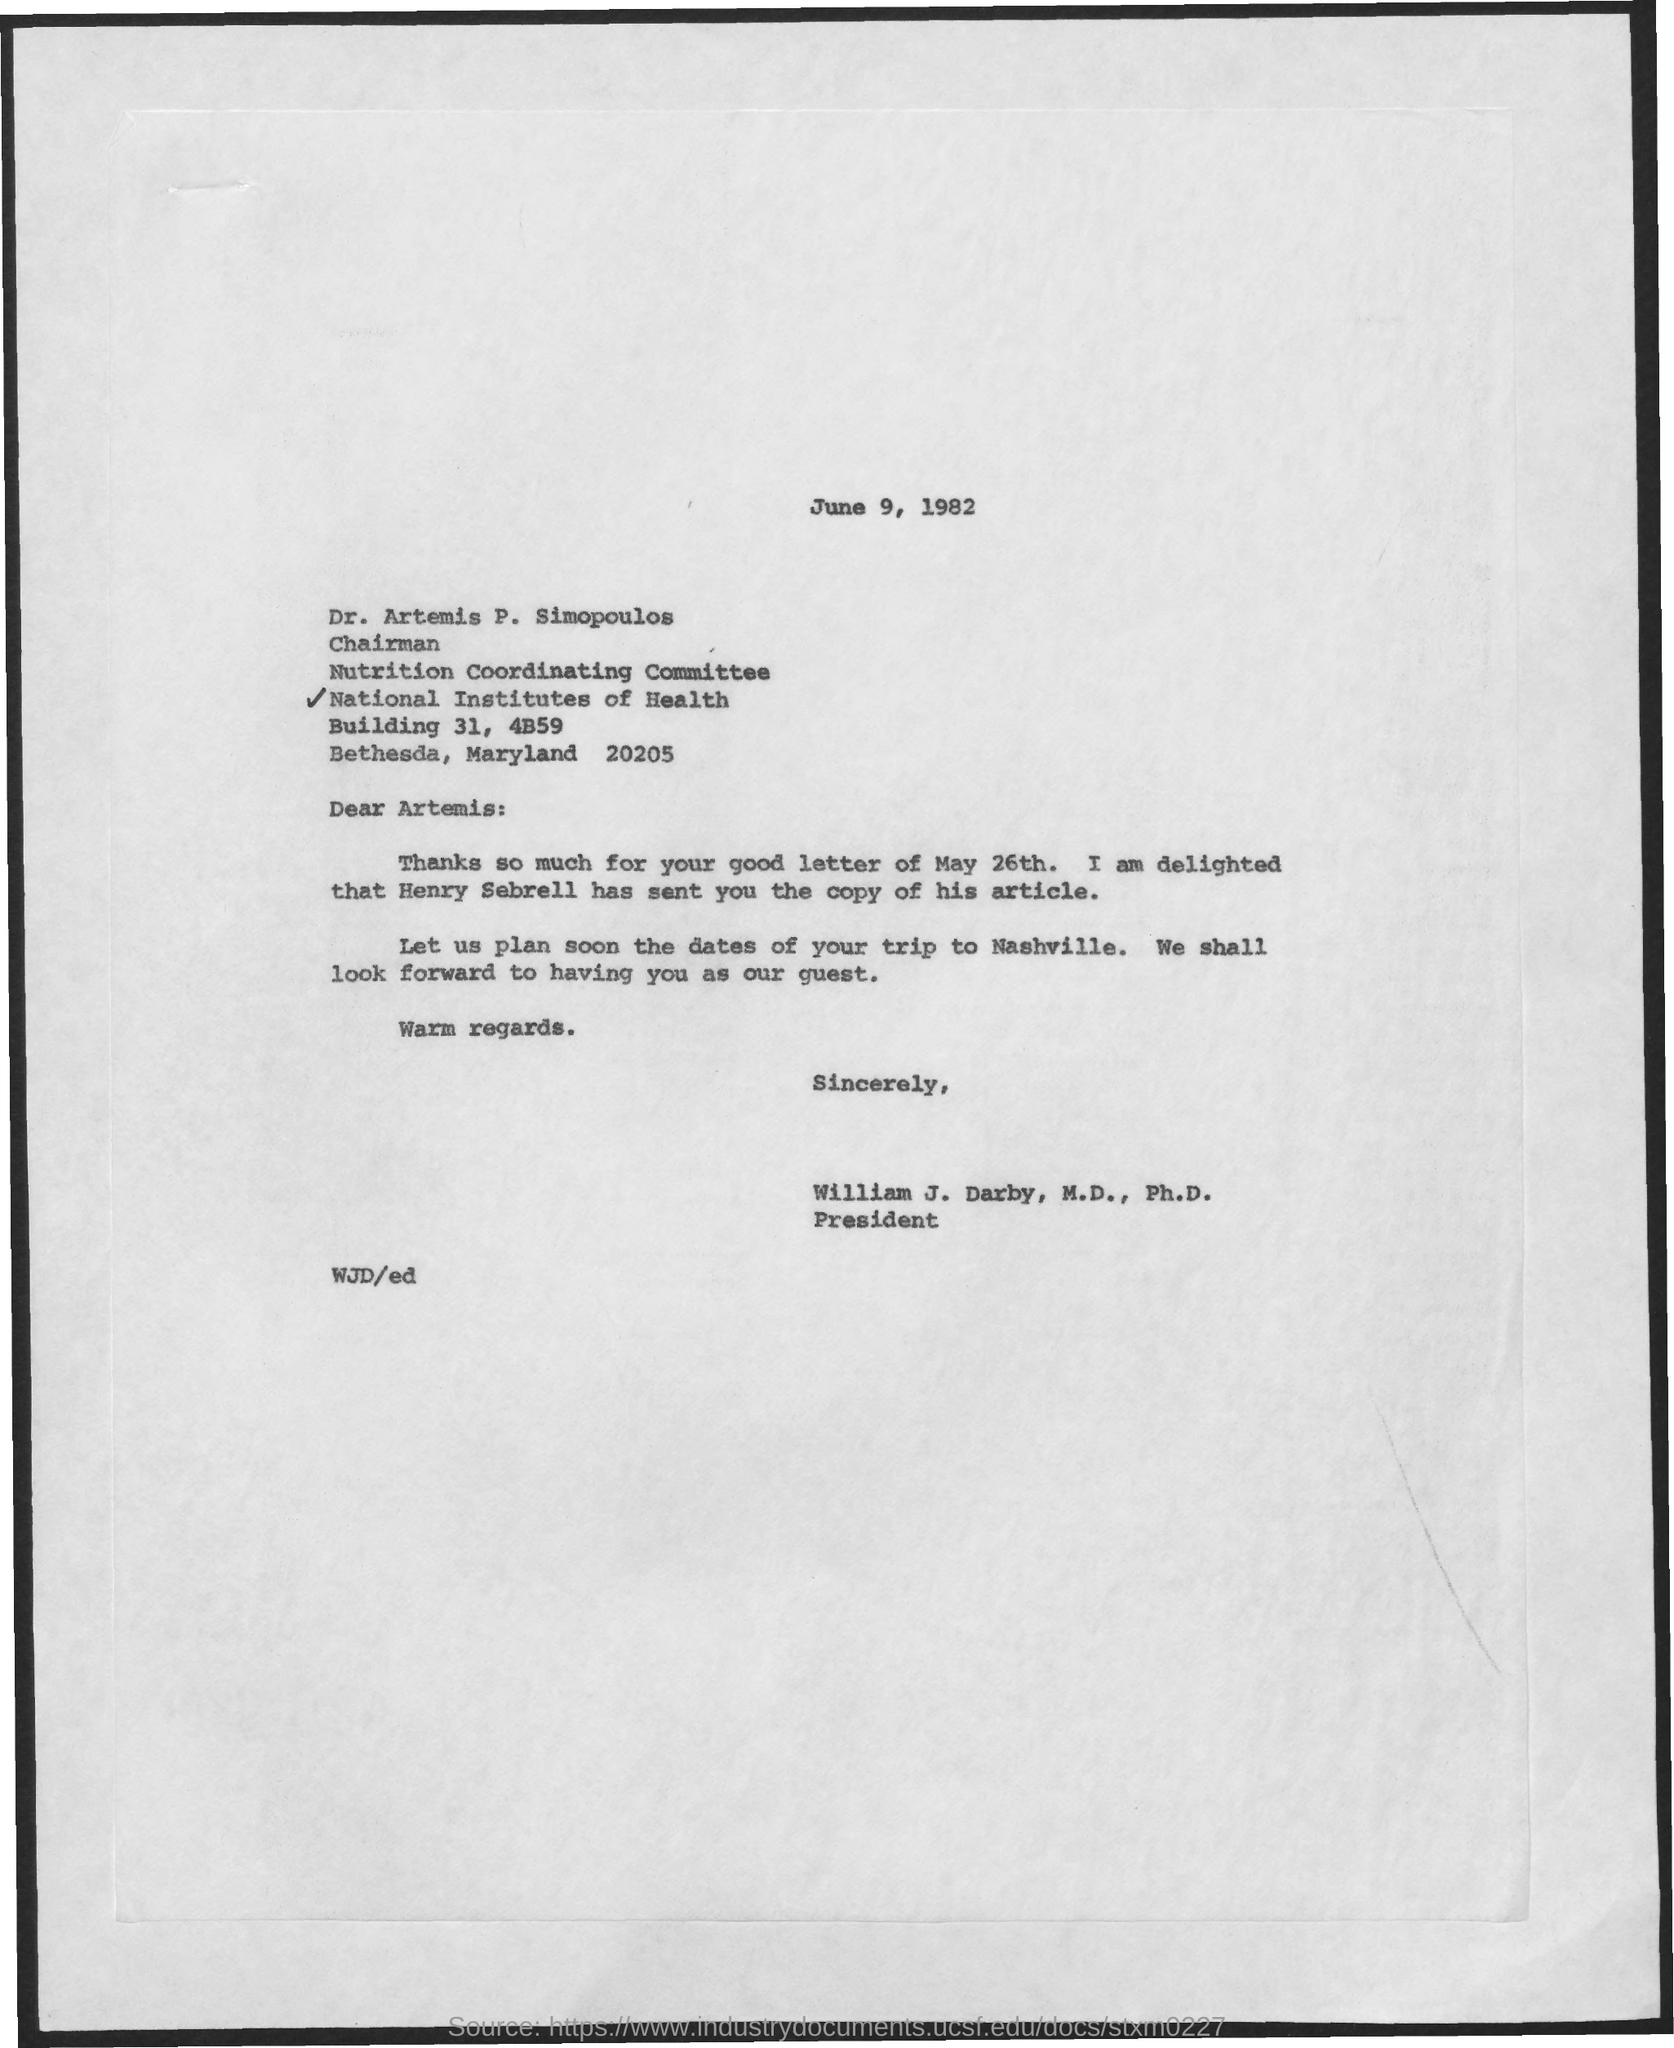What is the date mentioned in the given page ?
Give a very brief answer. June 9, 1982. What is the designation of dr. artemis p. simopoulos mentioned ?
Offer a very short reply. Chairman. 